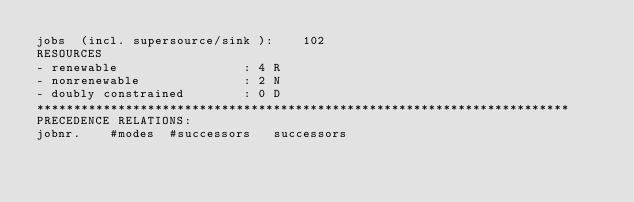<code> <loc_0><loc_0><loc_500><loc_500><_ObjectiveC_>jobs  (incl. supersource/sink ):	102
RESOURCES
- renewable                 : 4 R
- nonrenewable              : 2 N
- doubly constrained        : 0 D
************************************************************************
PRECEDENCE RELATIONS:
jobnr.    #modes  #successors   successors</code> 